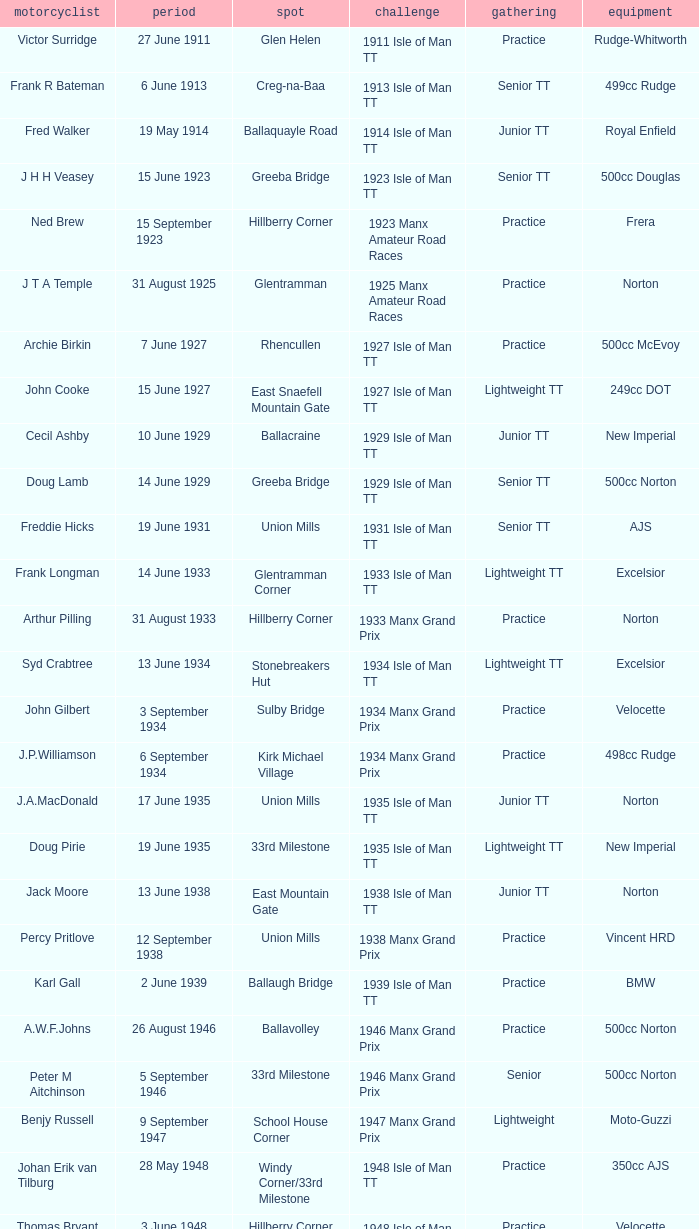What type of machinery did keith t. gawler use for riding? 499cc Norton. 